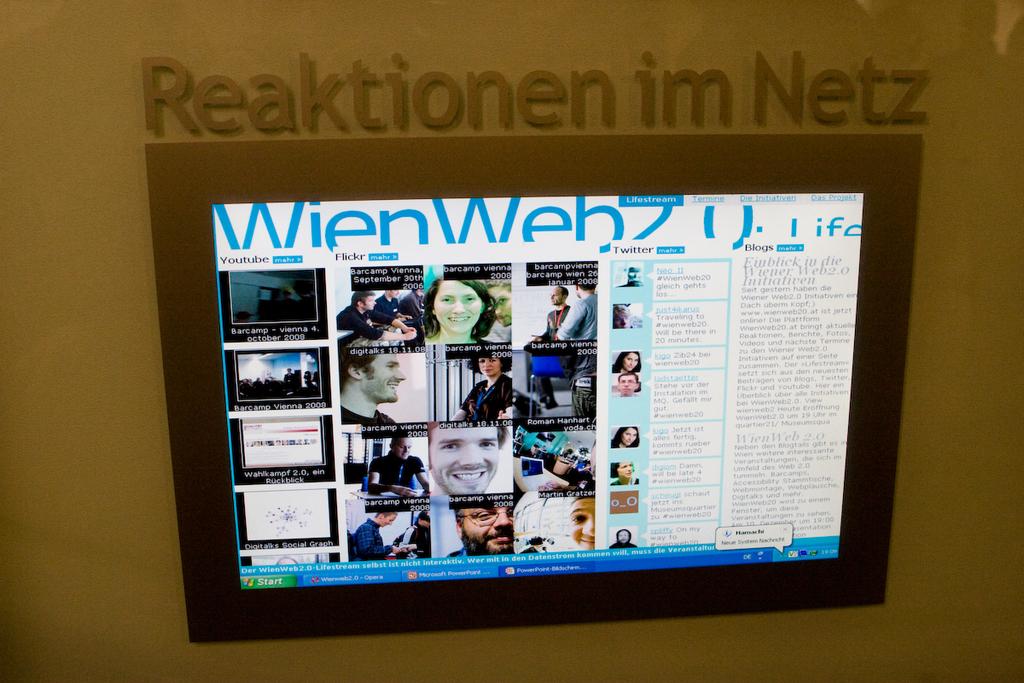What is the title above the display screen?
Provide a succinct answer. Reaktionen im netz. What version of wienweb is this?
Make the answer very short. 2.0. 